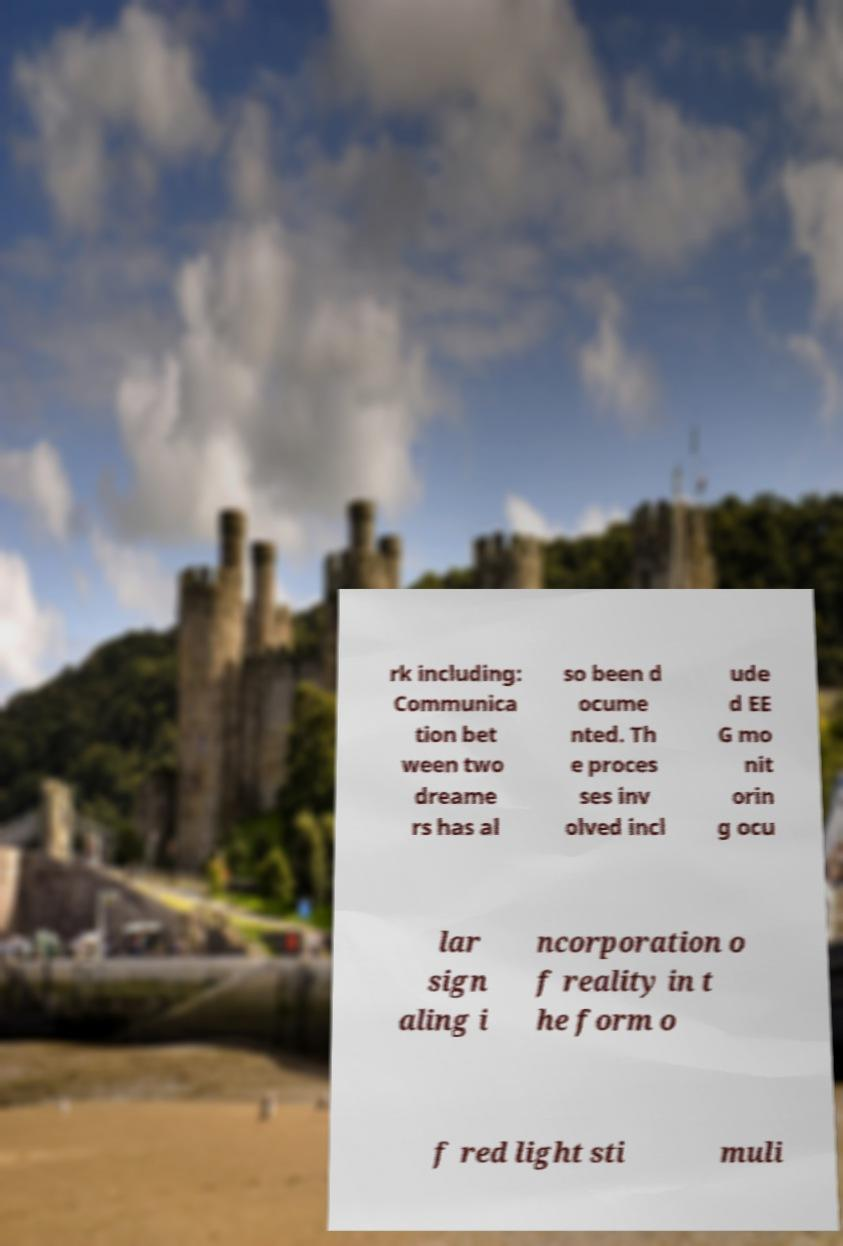Please read and relay the text visible in this image. What does it say? rk including: Communica tion bet ween two dreame rs has al so been d ocume nted. Th e proces ses inv olved incl ude d EE G mo nit orin g ocu lar sign aling i ncorporation o f reality in t he form o f red light sti muli 